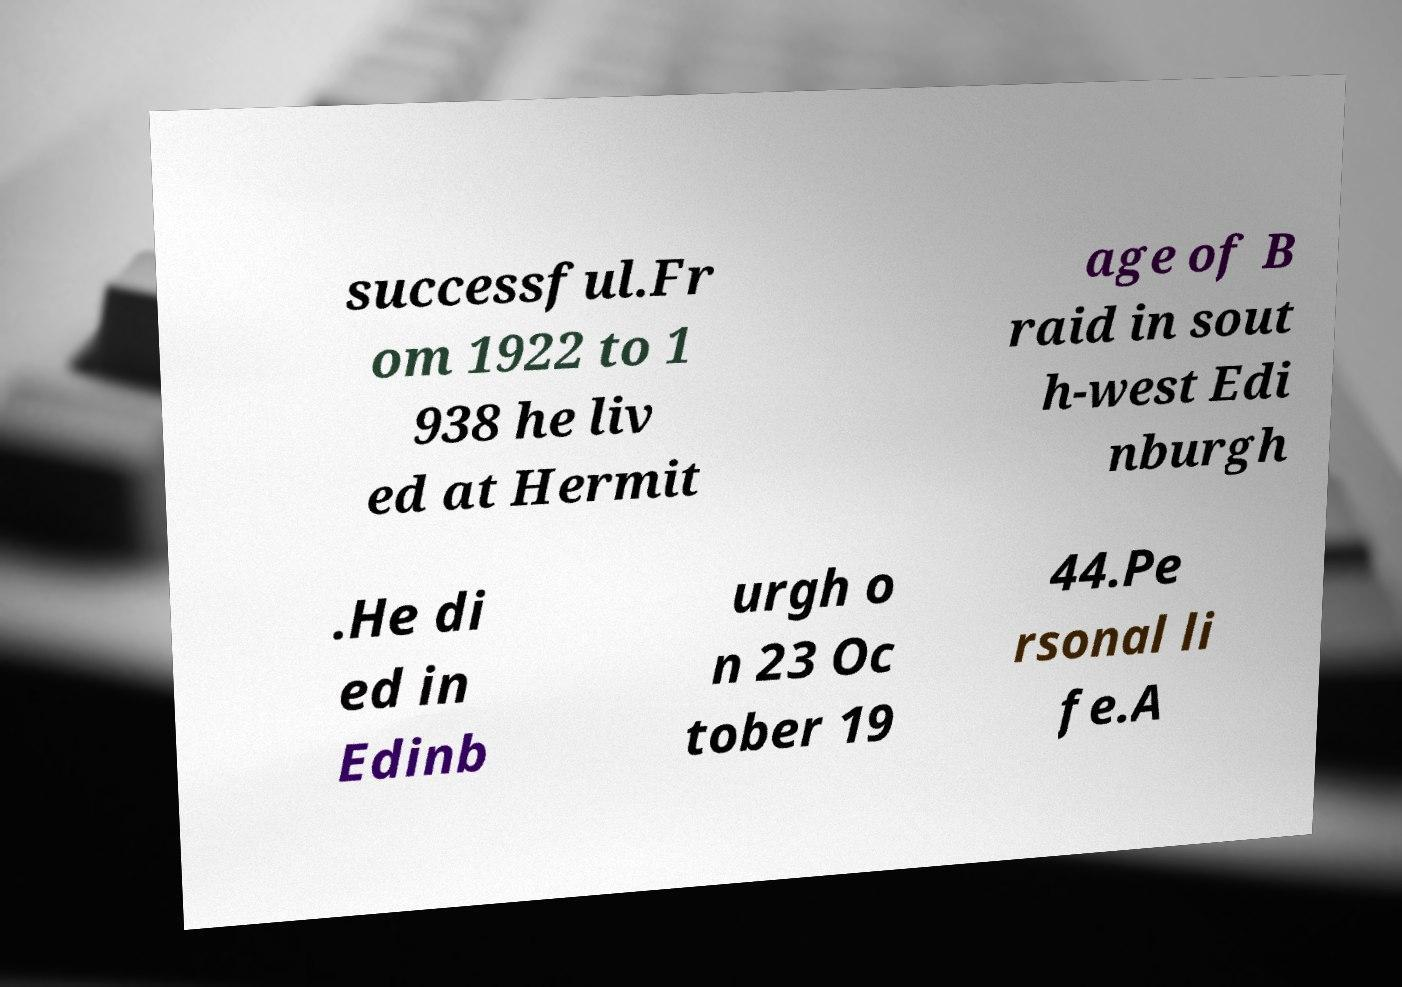Could you extract and type out the text from this image? successful.Fr om 1922 to 1 938 he liv ed at Hermit age of B raid in sout h-west Edi nburgh .He di ed in Edinb urgh o n 23 Oc tober 19 44.Pe rsonal li fe.A 